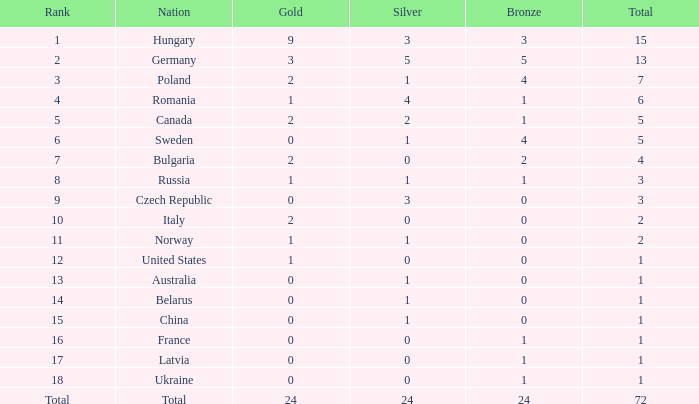What nation has 0 as the silver, 1 as the bronze, with 18 as the rank? Ukraine. 